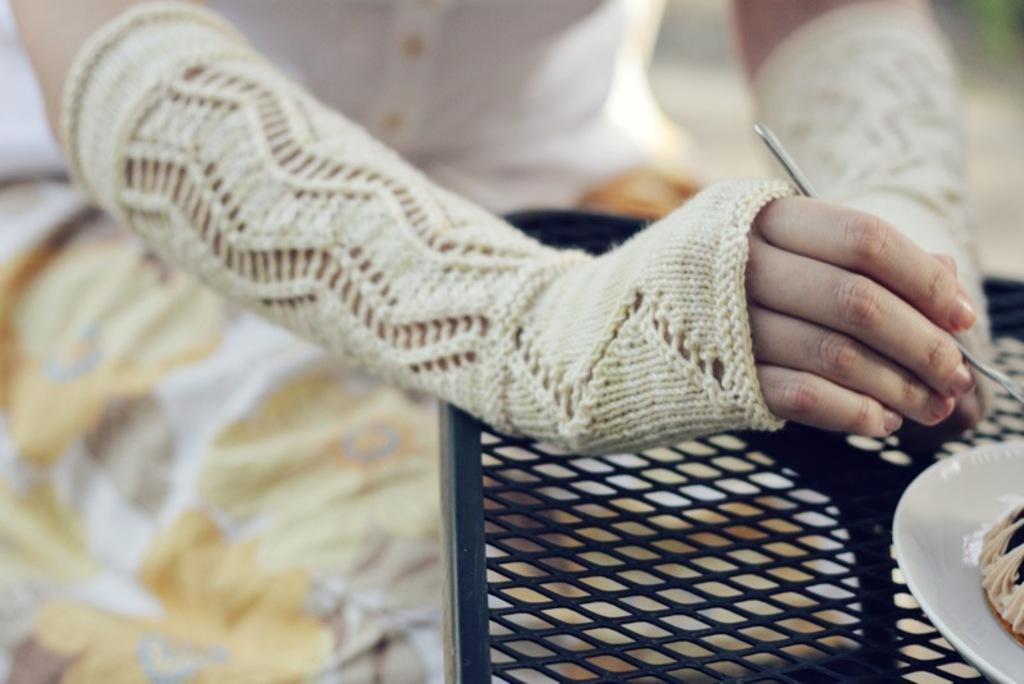How would you summarize this image in a sentence or two? In this image in the front there is a plate which is white in colour and on the plate there is food. In the center there is a chair which is black in colour and in the background there is a person holding an object in hand. 